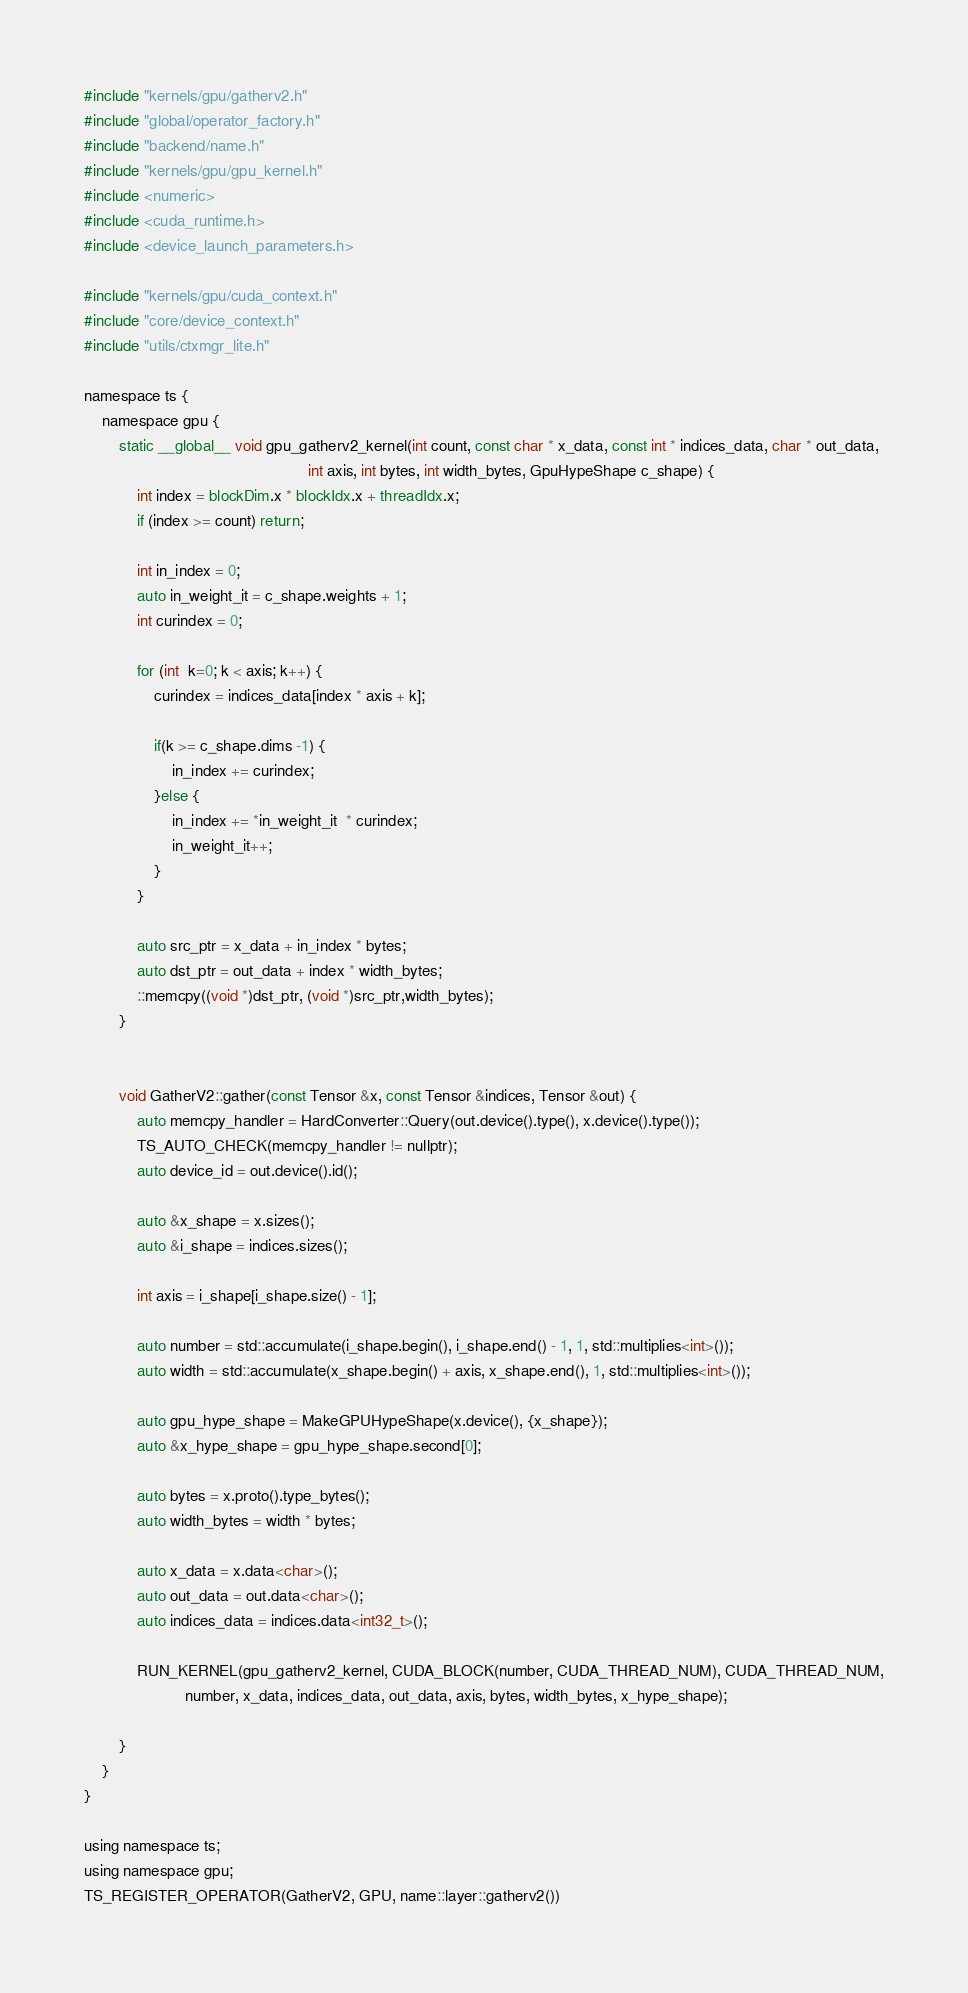Convert code to text. <code><loc_0><loc_0><loc_500><loc_500><_Cuda_>
#include "kernels/gpu/gatherv2.h"
#include "global/operator_factory.h"
#include "backend/name.h"
#include "kernels/gpu/gpu_kernel.h"
#include <numeric>
#include <cuda_runtime.h>
#include <device_launch_parameters.h>

#include "kernels/gpu/cuda_context.h"
#include "core/device_context.h"
#include "utils/ctxmgr_lite.h"

namespace ts {
    namespace gpu {
        static __global__ void gpu_gatherv2_kernel(int count, const char * x_data, const int * indices_data, char * out_data, 
                                                   int axis, int bytes, int width_bytes, GpuHypeShape c_shape) {
            int index = blockDim.x * blockIdx.x + threadIdx.x;
            if (index >= count) return;

            int in_index = 0;
            auto in_weight_it = c_shape.weights + 1;
            int curindex = 0;
            
            for (int  k=0; k < axis; k++) {
                curindex = indices_data[index * axis + k];

                if(k >= c_shape.dims -1) {
                    in_index += curindex;
                }else {
                    in_index += *in_weight_it  * curindex;
                    in_weight_it++;
                }
            }

            auto src_ptr = x_data + in_index * bytes;
            auto dst_ptr = out_data + index * width_bytes;
            ::memcpy((void *)dst_ptr, (void *)src_ptr,width_bytes);
        }


        void GatherV2::gather(const Tensor &x, const Tensor &indices, Tensor &out) {
            auto memcpy_handler = HardConverter::Query(out.device().type(), x.device().type());
            TS_AUTO_CHECK(memcpy_handler != nullptr);
            auto device_id = out.device().id();

            auto &x_shape = x.sizes();
            auto &i_shape = indices.sizes();

            int axis = i_shape[i_shape.size() - 1];

            auto number = std::accumulate(i_shape.begin(), i_shape.end() - 1, 1, std::multiplies<int>());
            auto width = std::accumulate(x_shape.begin() + axis, x_shape.end(), 1, std::multiplies<int>());

            auto gpu_hype_shape = MakeGPUHypeShape(x.device(), {x_shape});
            auto &x_hype_shape = gpu_hype_shape.second[0];

            auto bytes = x.proto().type_bytes();
            auto width_bytes = width * bytes;

            auto x_data = x.data<char>();
            auto out_data = out.data<char>();
            auto indices_data = indices.data<int32_t>();

            RUN_KERNEL(gpu_gatherv2_kernel, CUDA_BLOCK(number, CUDA_THREAD_NUM), CUDA_THREAD_NUM,
                       number, x_data, indices_data, out_data, axis, bytes, width_bytes, x_hype_shape);

        }
    }
}

using namespace ts;
using namespace gpu;
TS_REGISTER_OPERATOR(GatherV2, GPU, name::layer::gatherv2())
</code> 